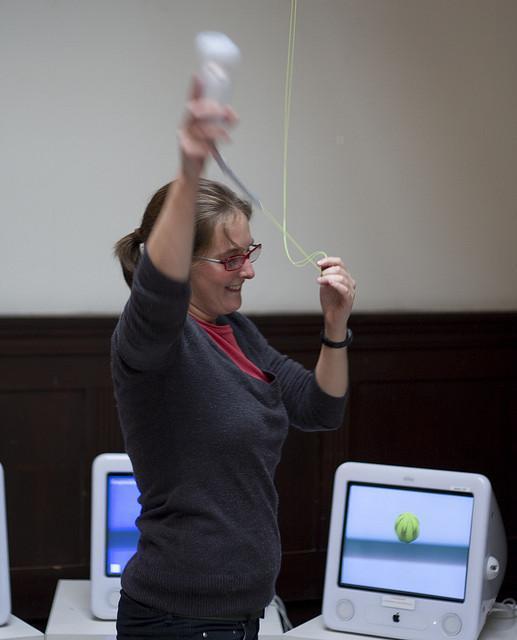What kind of computer is near the woman in blue?
Make your selection from the four choices given to correctly answer the question.
Options: Acer, macintosh, hp, dell. Macintosh. 